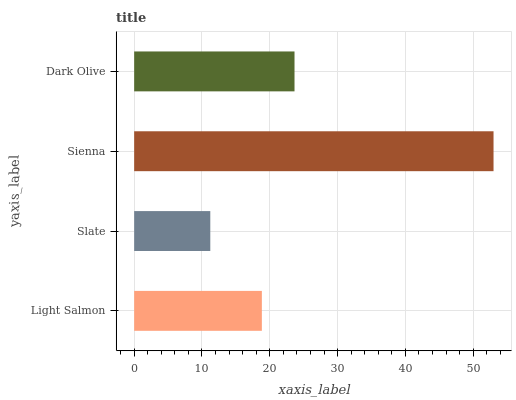Is Slate the minimum?
Answer yes or no. Yes. Is Sienna the maximum?
Answer yes or no. Yes. Is Sienna the minimum?
Answer yes or no. No. Is Slate the maximum?
Answer yes or no. No. Is Sienna greater than Slate?
Answer yes or no. Yes. Is Slate less than Sienna?
Answer yes or no. Yes. Is Slate greater than Sienna?
Answer yes or no. No. Is Sienna less than Slate?
Answer yes or no. No. Is Dark Olive the high median?
Answer yes or no. Yes. Is Light Salmon the low median?
Answer yes or no. Yes. Is Light Salmon the high median?
Answer yes or no. No. Is Sienna the low median?
Answer yes or no. No. 